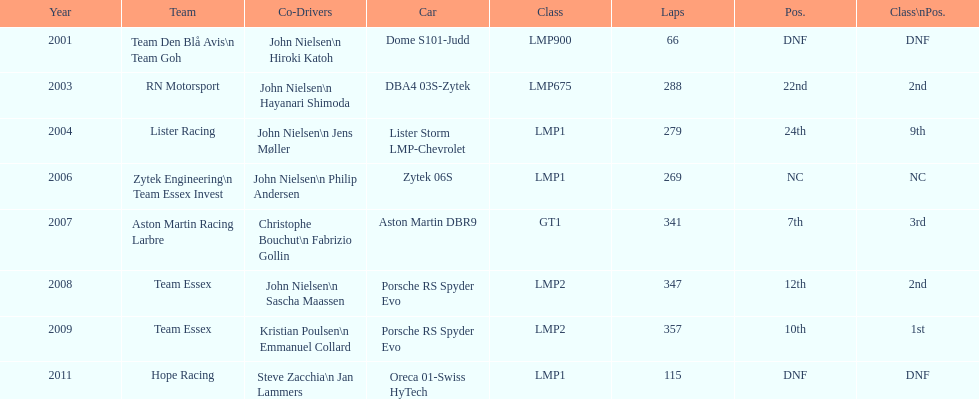At the 24 hours of le mans, who was casper elgaard's primary co-driver? John Nielsen. 